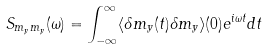<formula> <loc_0><loc_0><loc_500><loc_500>S _ { m _ { y } m _ { y } } ( \omega ) = \int _ { - \infty } ^ { \infty } \langle \delta m _ { y } ( t ) \delta m _ { y } \rangle ( 0 ) e ^ { i \omega t } d t</formula> 